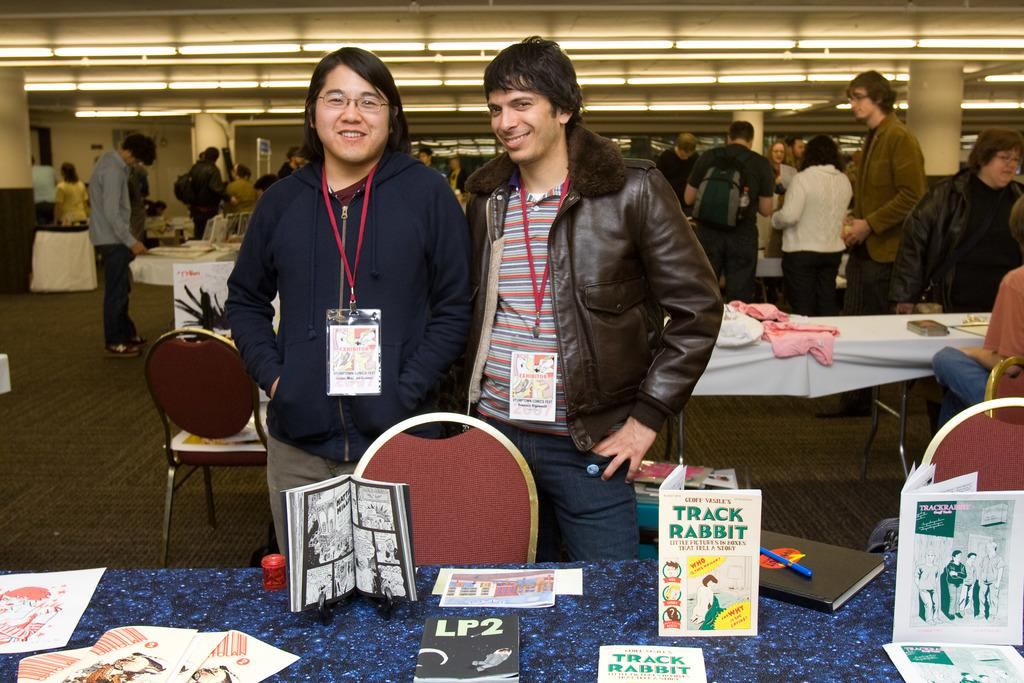<image>
Give a short and clear explanation of the subsequent image. Two men taking a picture behind a sign that says Track Rabbit on the table. 